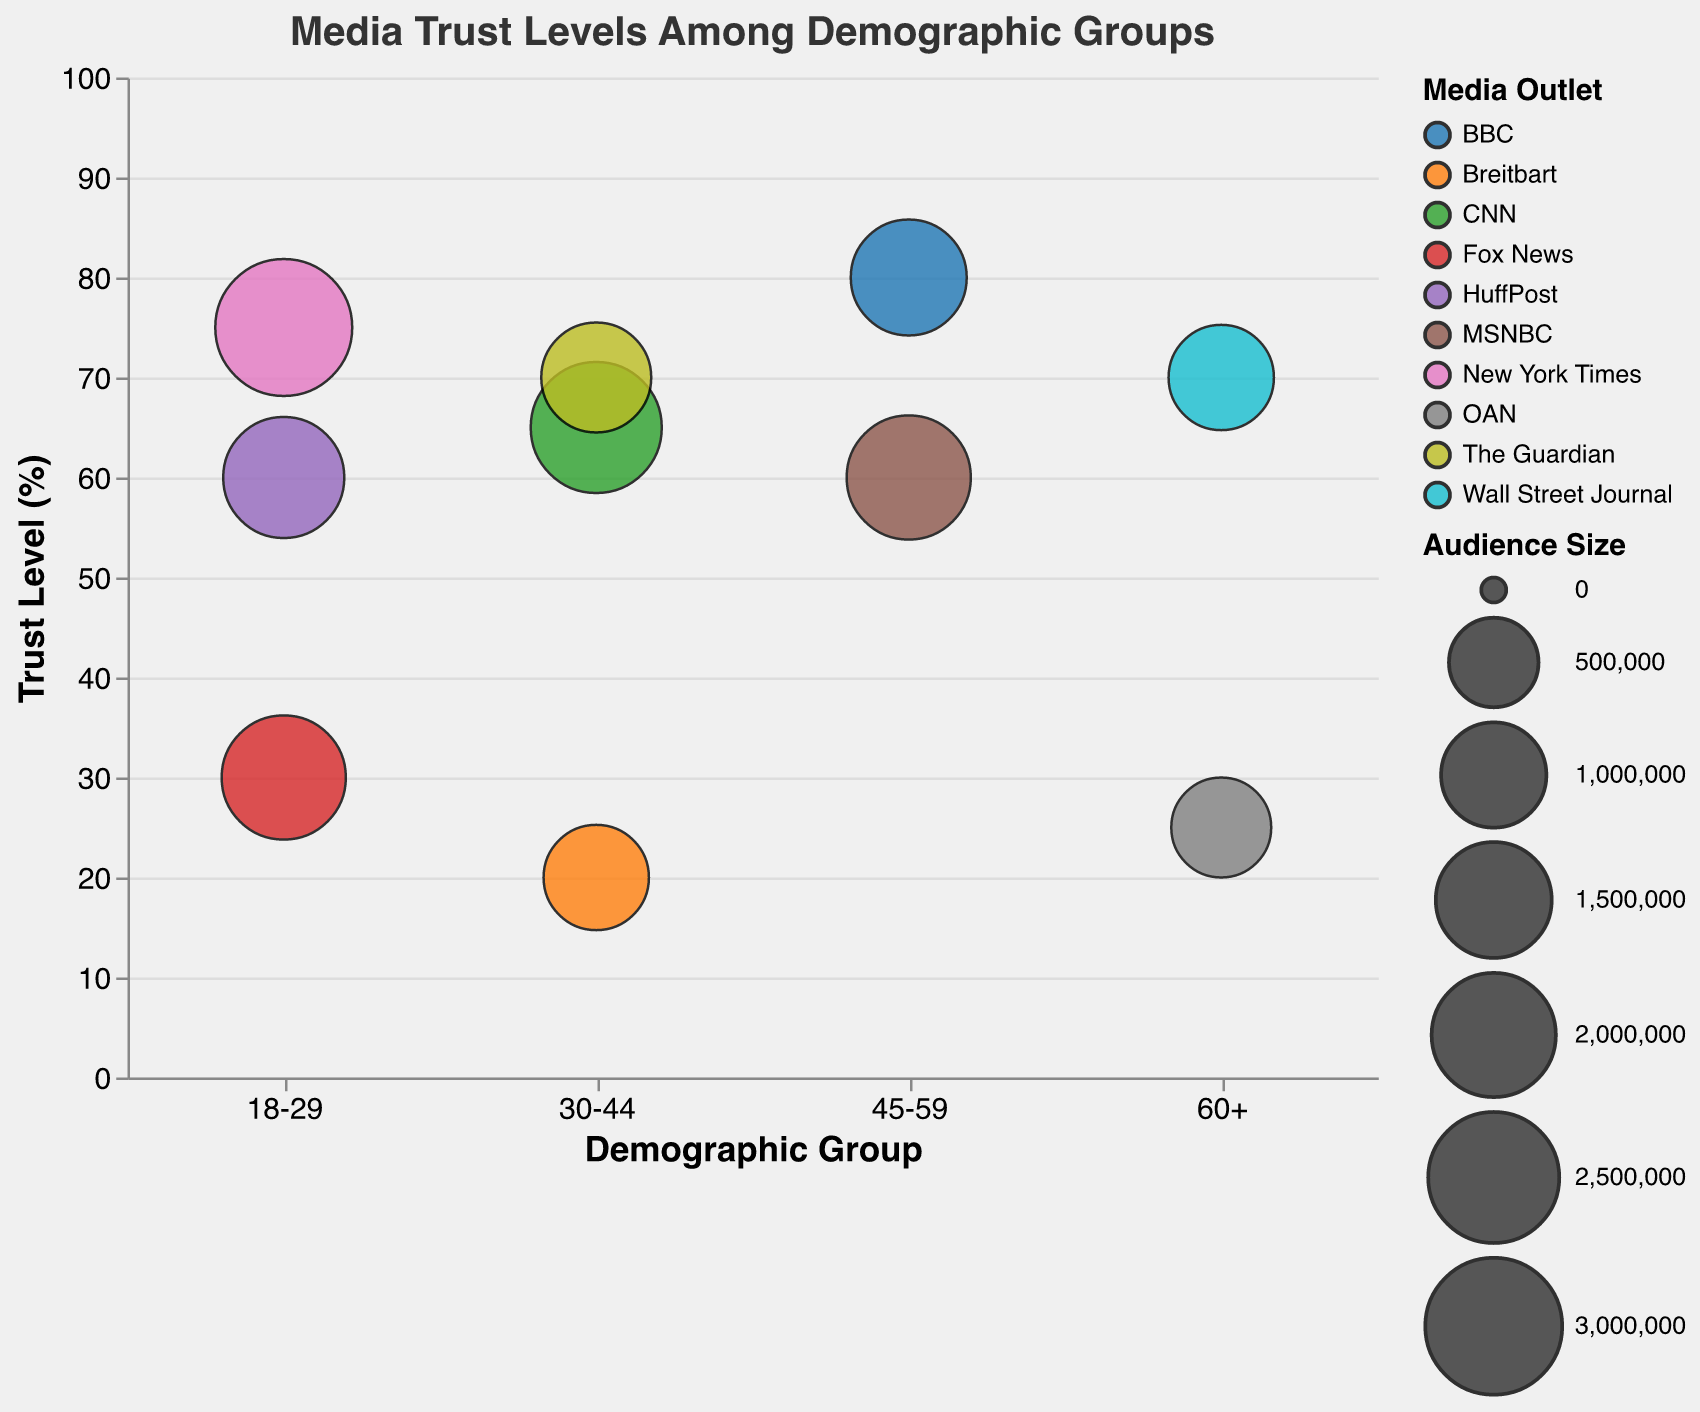What's the title of the figure? The title is located at the top of the figure and typically provides a brief description of what the data visualizes. In this case, it reads "Media Trust Levels Among Demographic Groups."
Answer: Media Trust Levels Among Demographic Groups How many demographic groups are represented in the chart? To determine the number of demographic groups, look at the unique categories along the x-axis. The x-axis shows "18-29", "30-44", "45-59", and "60+", indicating there are 4 distinct demographic groups in the chart.
Answer: 4 Which media outlet has the highest trust level among the 45-59 age group? Examine the circles within the "45-59" demographic group on the x-axis and find the one that corresponds to the highest position on the y-axis. The circle at the highest position represents BBC with a trust level of 80.
Answer: BBC What is the audience size for the New York Times in the 18-29 age group? Look for the circle that represents the New York Times within the "18-29" demographic group. Check the tooltip or the size of the circle to find that the audience size is given as 3,000,000.
Answer: 3,000,000 Which demographic group trusts CNN more than Fox News and by how much? Identify the circles representing CNN and Fox News within each demographic group. Compare their y-axis positions (trust levels). In the "30-44" group, CNN (65) is higher than Fox News (not present), so no comparison here. But for "18-29," Fox News (30) compared with New York Times, which is higher.
Answer: 65 - 30 = 35 What is the average trust level for media outlets within the 18-29 demographic group? Find the trust levels for all media outlets within the "18-29" demographic group: New York Times (75), Fox News (30), HuffPost (60). Calculate the average: (75 + 30 + 60) / 3 = 55.
Answer: 55 Which media outlet has the smallest overall audience size in the chart? Examine the circles for all demographic groups and identify the one with the smallest size. The tooltip indicates the size, and OAN in the "60+" group has the smallest audience size with 800,000.
Answer: OAN How do the trust levels for The Guardian in the 30-44 demographic group compare to the trust levels for Fox News in the 18-29 demographic group? Locate The Guardian in the "30-44" group (trust level 70) and Fox News in the "18-29" group (trust level 30). Compare their y-axis positions: 70 is higher than 30.
Answer: 70 is higher than 30 Which demographic group has the most data points available in the chart? Count the number of circles for each demographic group. The "18-29" group has 3 circles, the "30-44" group has 3 circles, the "45-59" group has 2 circles, and the "60+" group has 2 circles. Therefore, "18-29" and "30-44" have the most data points.
Answer: 18-29 and 30-44 What is the difference in trust levels between the BBC and MSNBC in the 45-59 age group? Find the circles for BBC and MSNBC in the "45-59" group and note their trust levels: BBC (80) and MSNBC (60). The difference is calculated as 80 - 60 = 20.
Answer: 20 